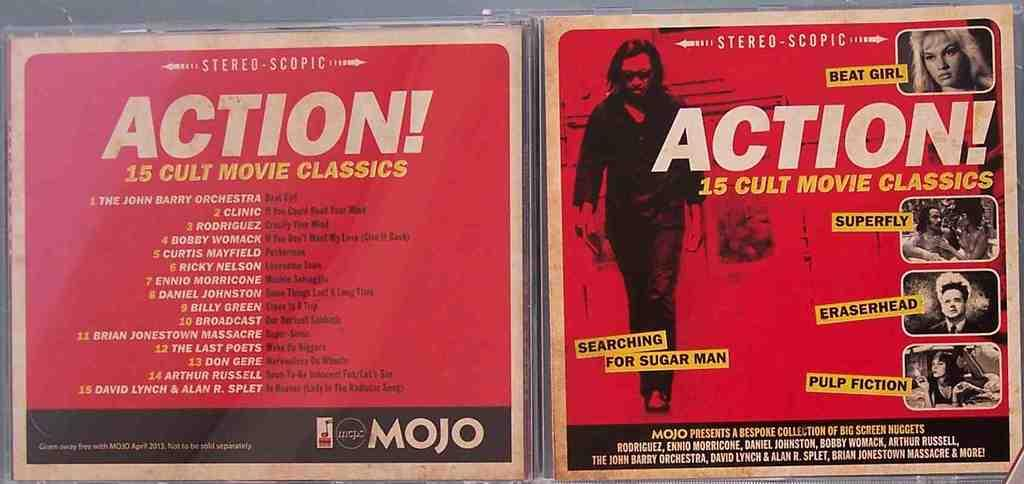<image>
Provide a brief description of the given image. The front and back of CD with a red cover listing the tracks which are all action movie soundtrack songs. 